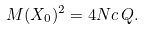Convert formula to latex. <formula><loc_0><loc_0><loc_500><loc_500>M ( X _ { 0 } ) ^ { 2 } = 4 N c \, Q .</formula> 